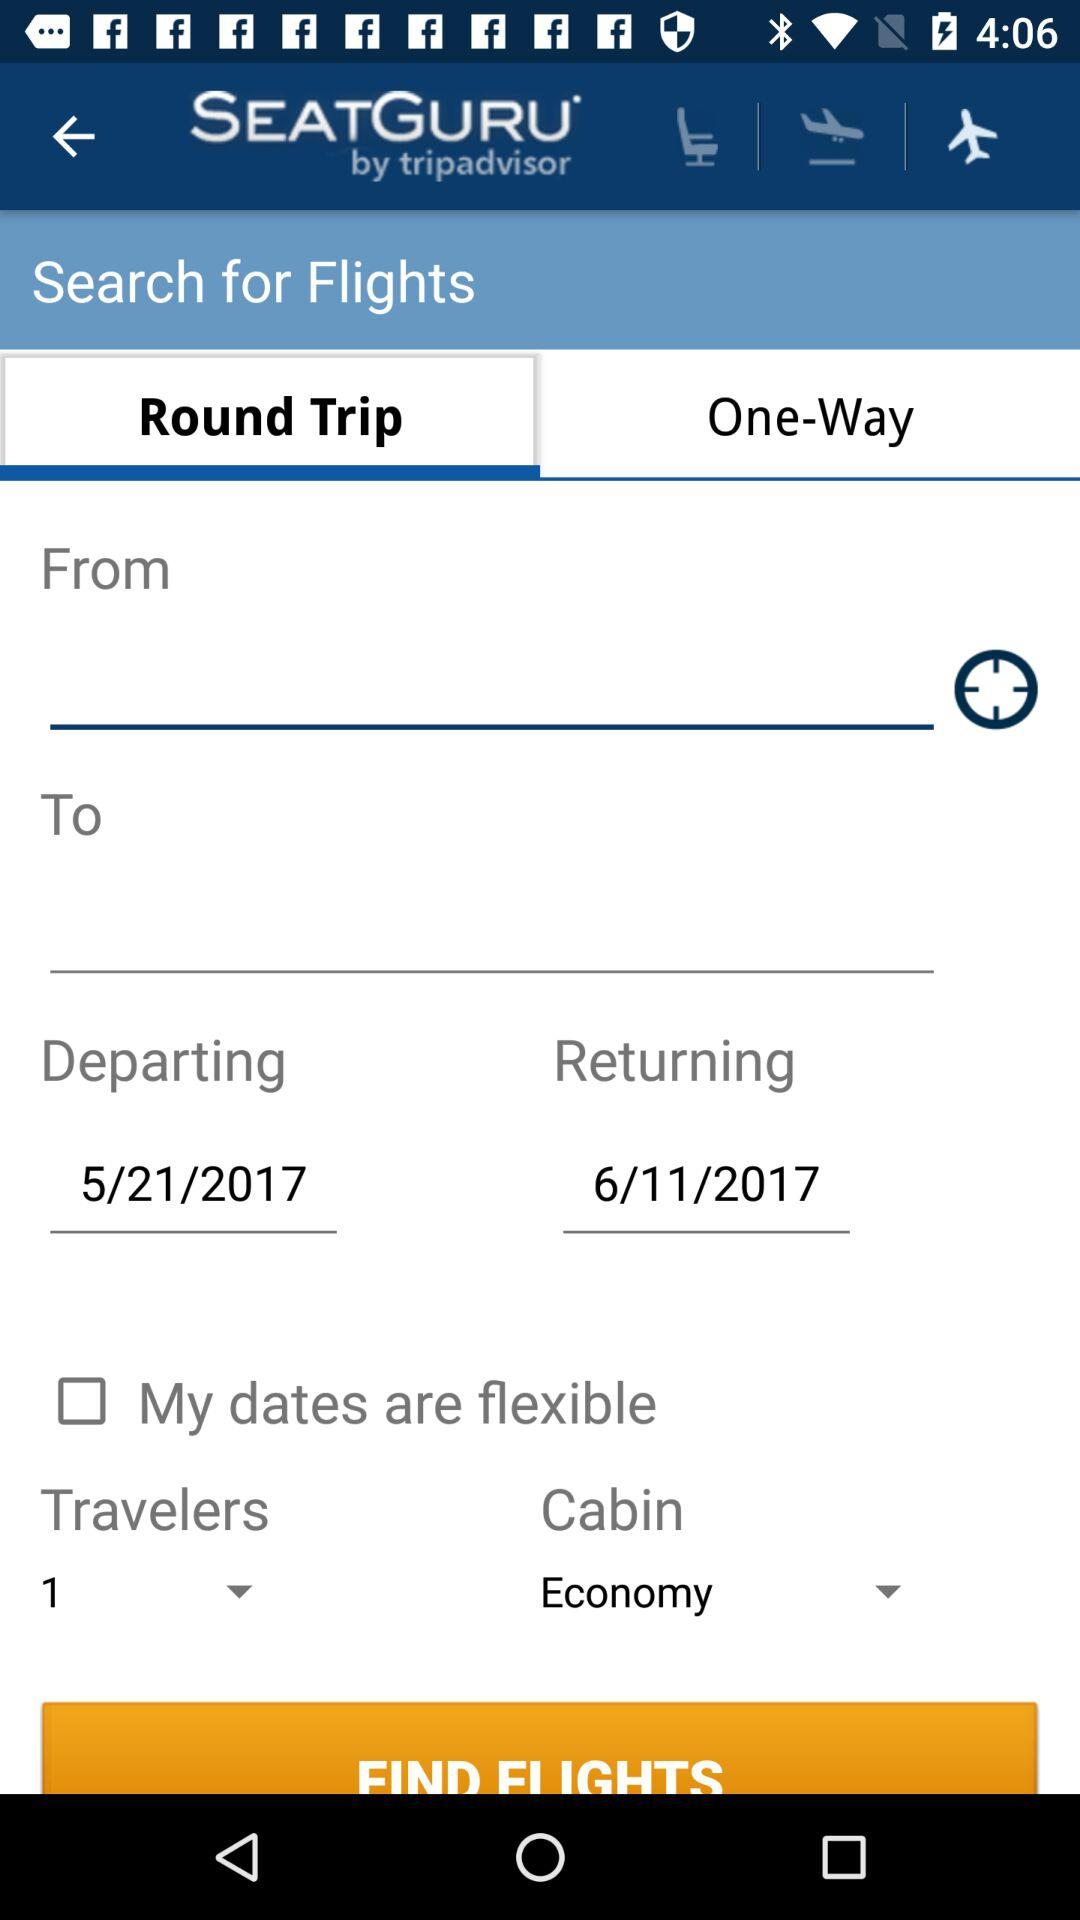What is the "Returning" date? The date is November 6, 2017. 